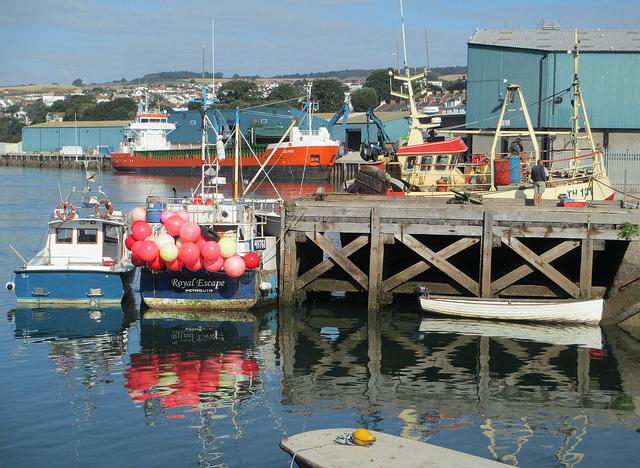Why are all those balloons in the boat? celebration 